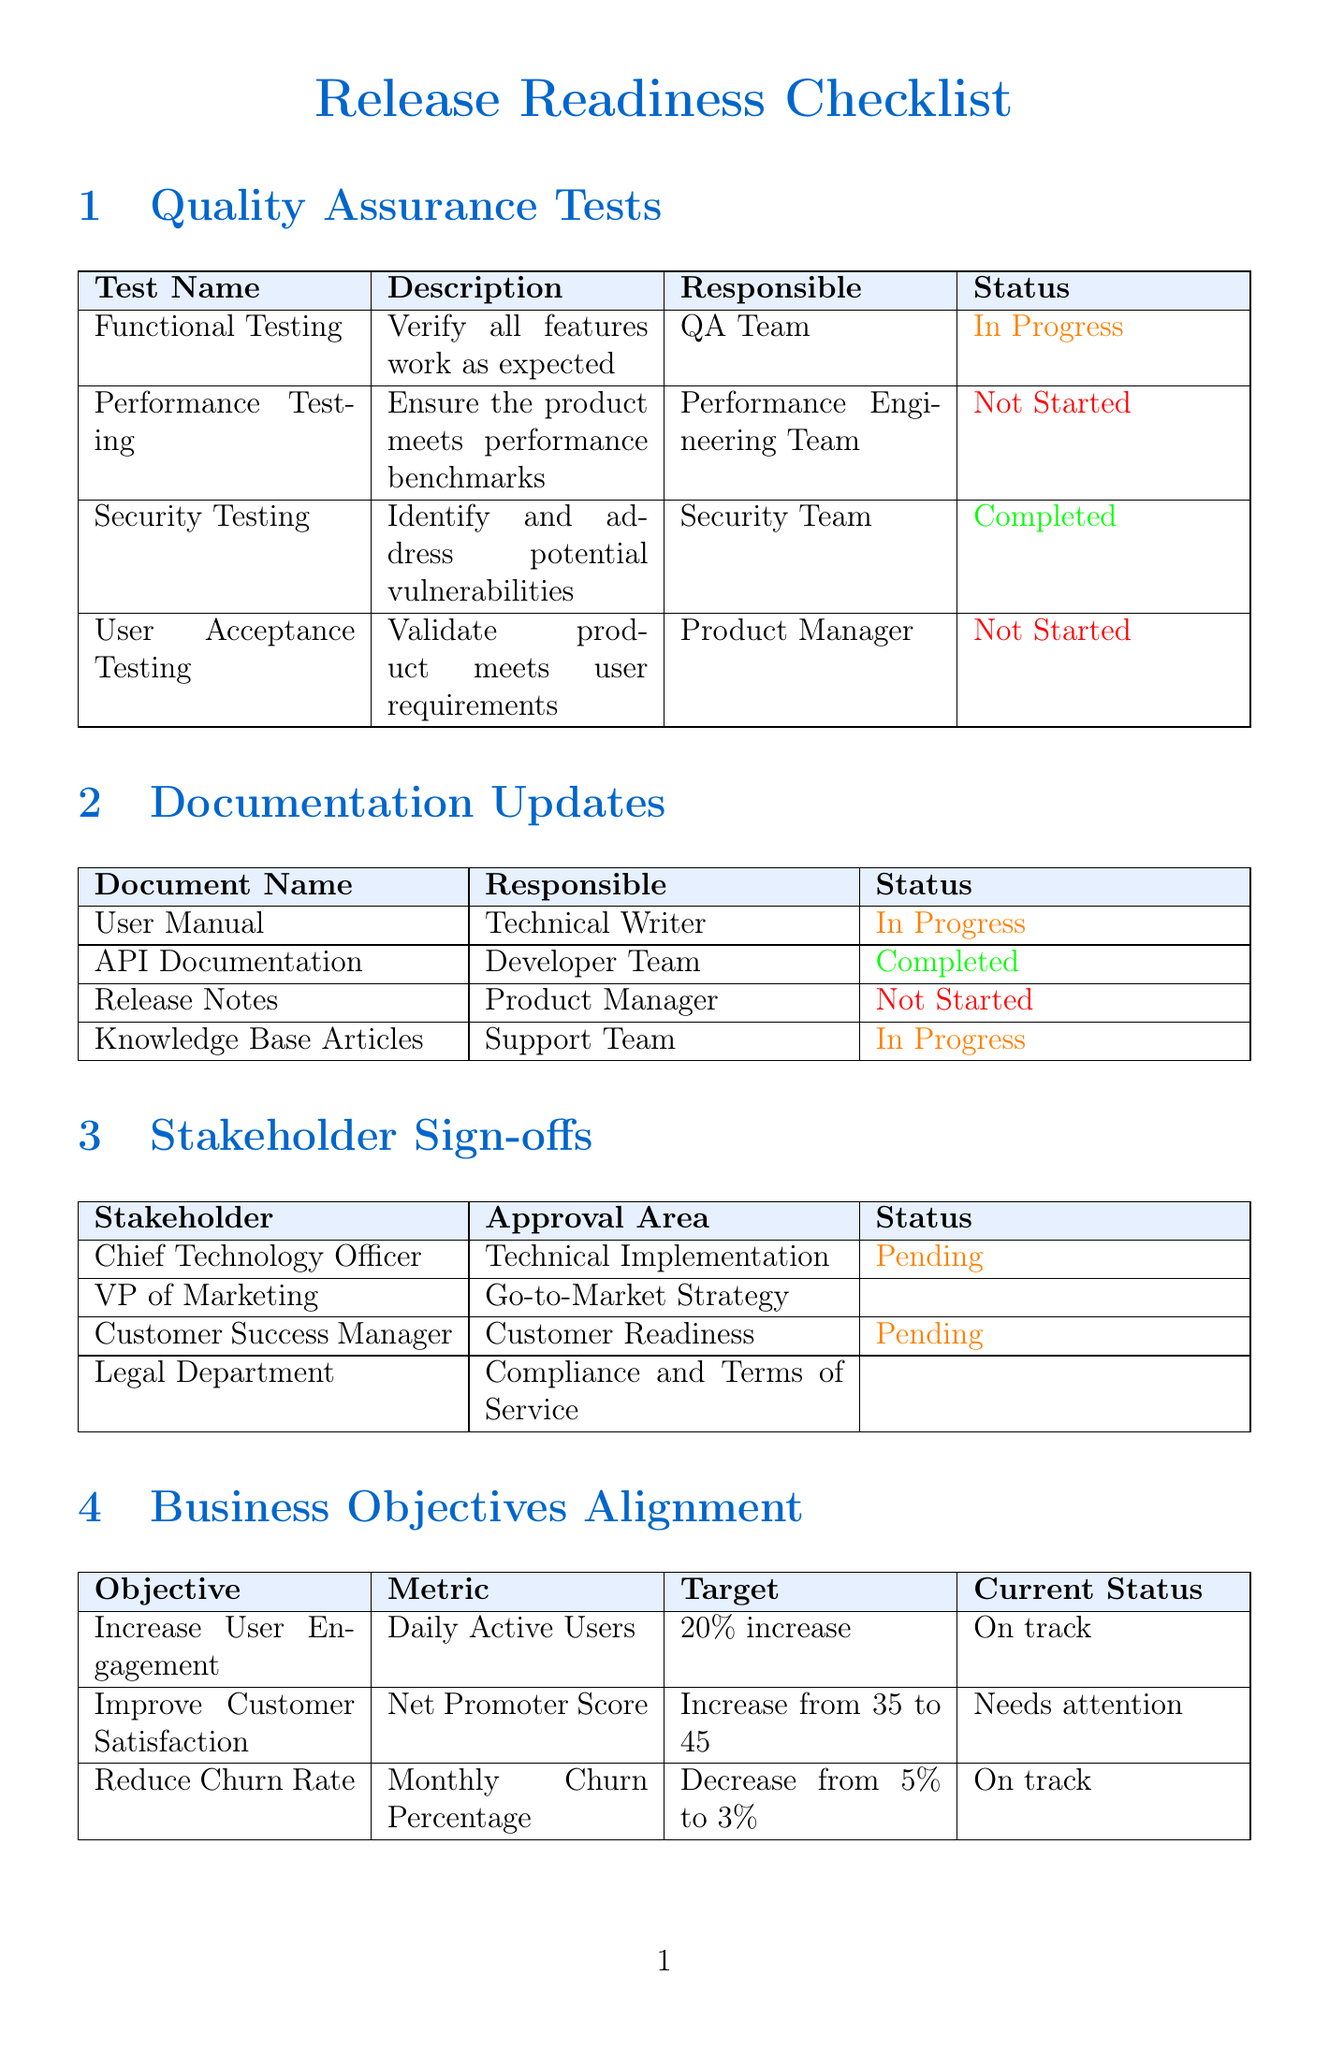What is the status of Functional Testing? Functional Testing is one of the quality assurance tests listed, and its status is currently "In Progress."
Answer: In Progress Who is responsible for the User Manual updates? The User Manual is assigned to the Technical Writer for updates, as indicated in the documentation updates section.
Answer: Technical Writer What is the approval status of the Chief Technology Officer? The Chief Technology Officer's approval status is noted as "Pending" in the stakeholder sign-offs section.
Answer: Pending How many business objectives are listed in the document? The document outlines three specific business objectives, which are summarized in the business objectives alignment section.
Answer: 3 Which feature has a high priority but is not ready for release? The Dashboard Customization feature has a medium priority and is "In final testing," which indicates it is not yet ready for release, despite its priority level.
Answer: Dashboard Customization What is the current status regarding the go/no-go decision? The go/no-go decision status is mentioned in the document, showing it is "On track for Go decision."
Answer: On track for Go decision What document is responsible for being updated by the Developer Team? The API Documentation is specifically assigned to the Developer Team for updates, as shown in the documentation updates table.
Answer: API Documentation What percentage increase is targeted for Daily Active Users? The increase targeted for Daily Active Users is defined as a "20% increase" within the business objectives alignment section.
Answer: 20% increase What is the decision date for the go/no-go decision? The go/no-go decision date is explicitly stated as "2023-06-15" in the document.
Answer: 2023-06-15 